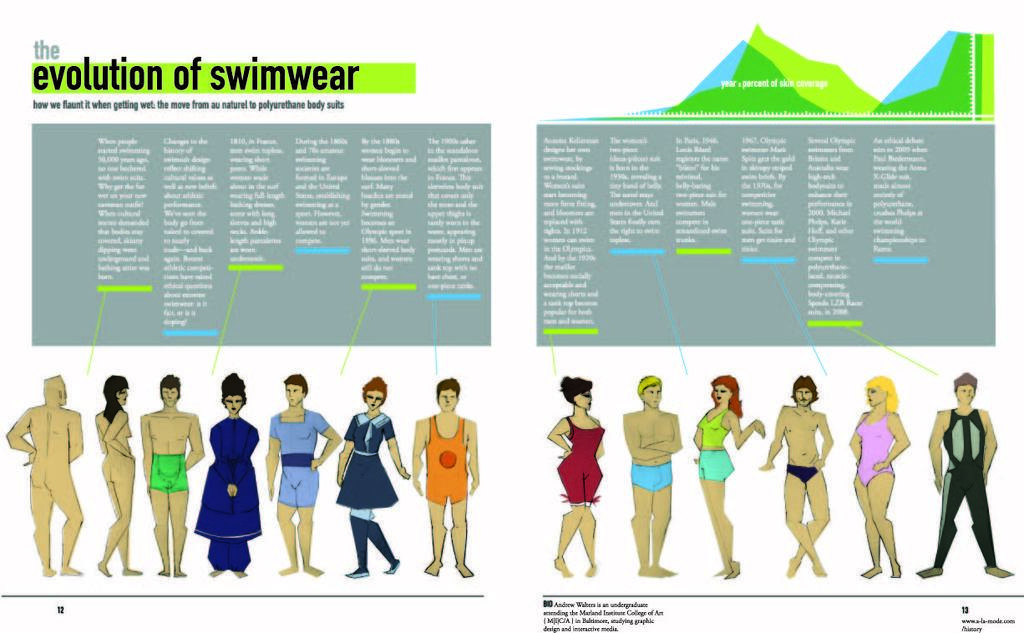What type of images are present in the image? There are graphic images of persons in the image. What else can be seen in the image besides the graphic images? Text is visible in the image. What type of authority figure is depicted in the image? There is no authority figure depicted in the image; it only contains graphic images of persons and text. How many circles can be seen in the image? There is no circle present in the image. 